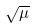Convert formula to latex. <formula><loc_0><loc_0><loc_500><loc_500>\sqrt { \mu }</formula> 